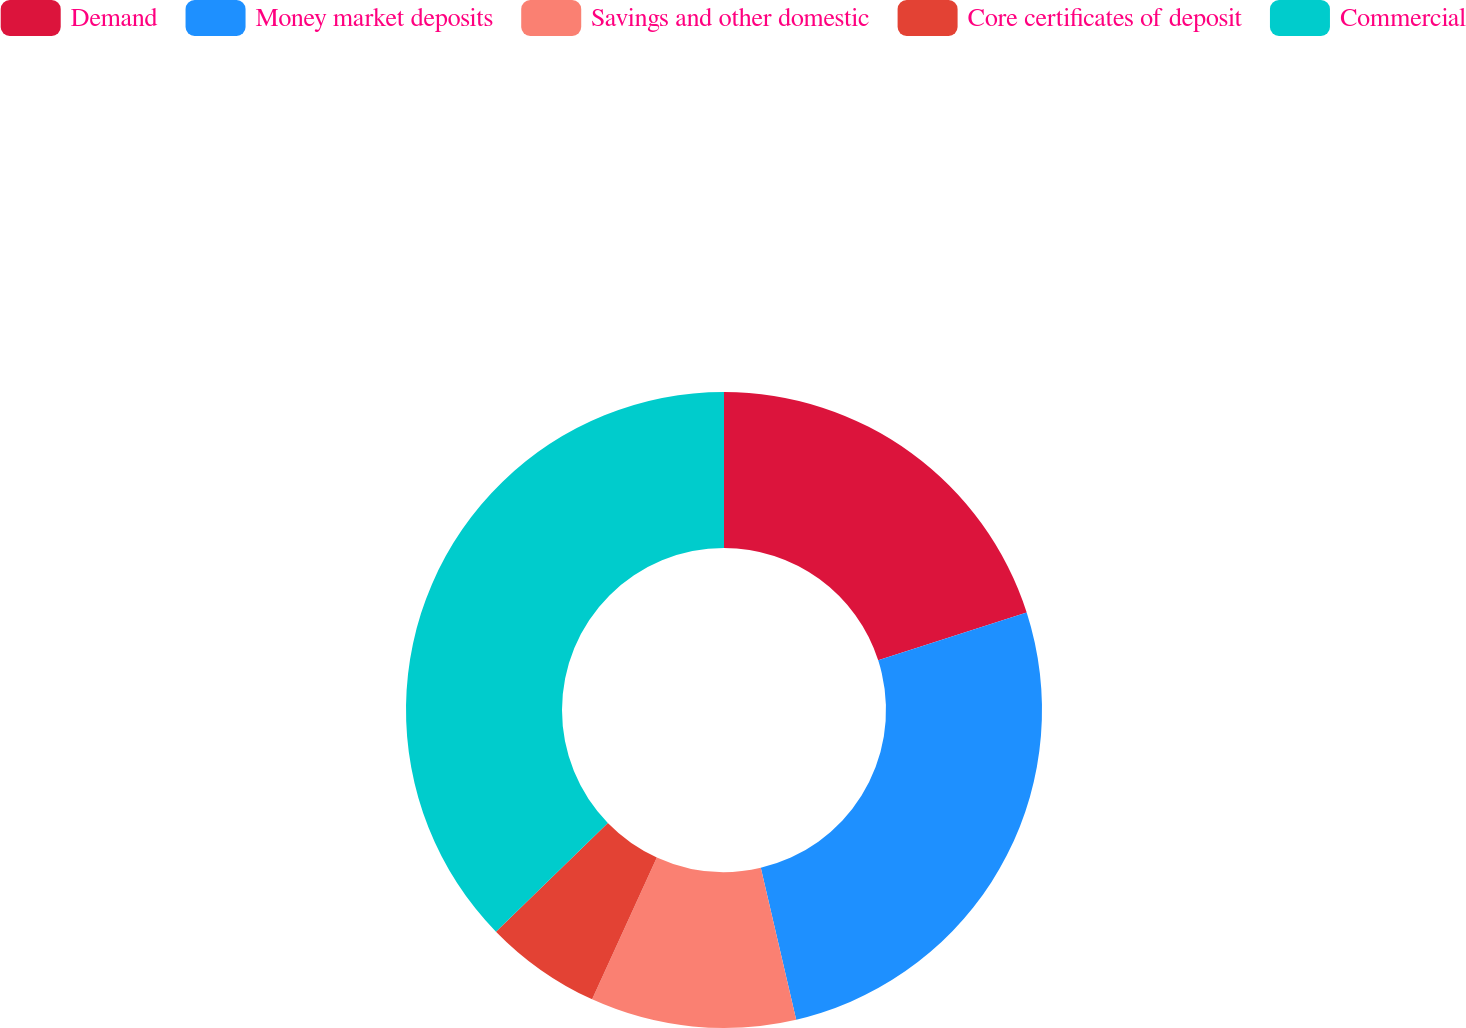Convert chart. <chart><loc_0><loc_0><loc_500><loc_500><pie_chart><fcel>Demand<fcel>Money market deposits<fcel>Savings and other domestic<fcel>Core certificates of deposit<fcel>Commercial<nl><fcel>20.04%<fcel>26.31%<fcel>10.45%<fcel>5.92%<fcel>37.27%<nl></chart> 